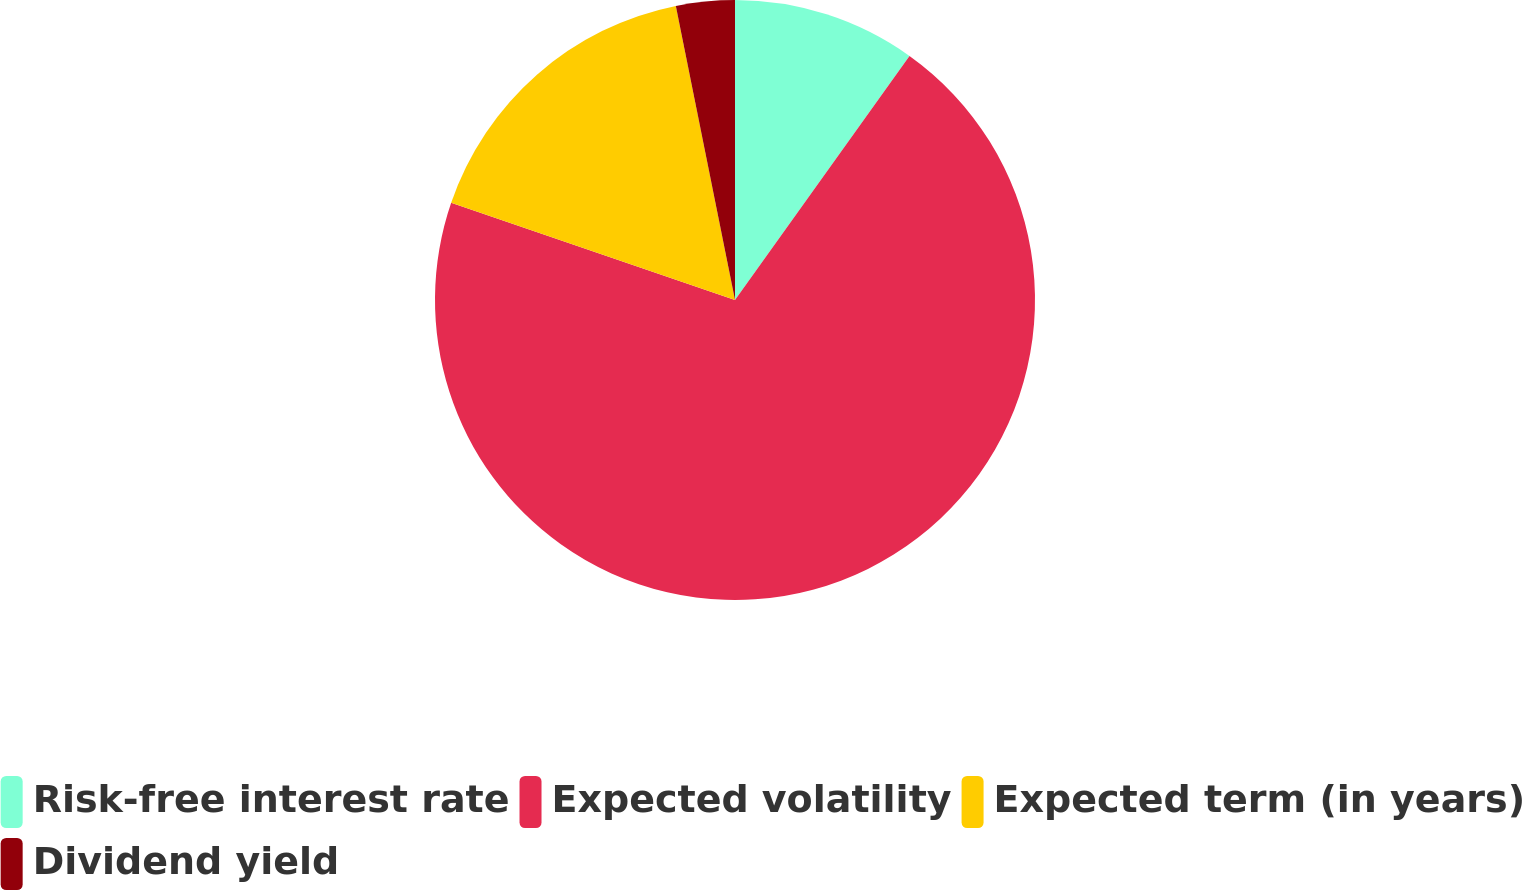<chart> <loc_0><loc_0><loc_500><loc_500><pie_chart><fcel>Risk-free interest rate<fcel>Expected volatility<fcel>Expected term (in years)<fcel>Dividend yield<nl><fcel>9.88%<fcel>70.37%<fcel>16.59%<fcel>3.16%<nl></chart> 